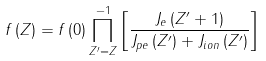<formula> <loc_0><loc_0><loc_500><loc_500>f \left ( Z \right ) = f \left ( 0 \right ) \prod _ { Z ^ { \prime } = Z } ^ { - 1 } \left [ \frac { J _ { e } \left ( Z ^ { \prime } + 1 \right ) } { J _ { p e } \left ( Z ^ { \prime } \right ) + J _ { i o n } \left ( Z ^ { \prime } \right ) } \right ]</formula> 